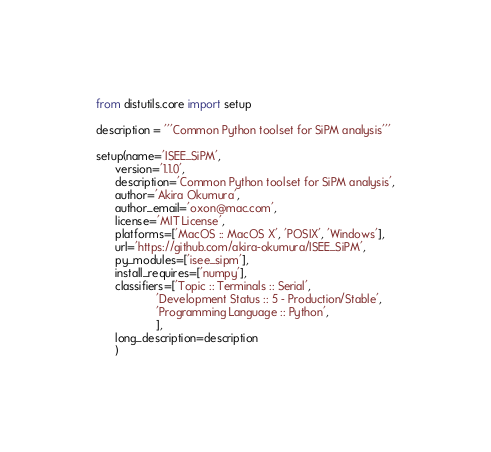<code> <loc_0><loc_0><loc_500><loc_500><_Python_>from distutils.core import setup

description = '''Common Python toolset for SiPM analysis'''

setup(name='ISEE_SiPM',
      version='1.1.0',
      description='Common Python toolset for SiPM analysis',
      author='Akira Okumura',
      author_email='oxon@mac.com',
      license='MIT License',
      platforms=['MacOS :: MacOS X', 'POSIX', 'Windows'],
      url='https://github.com/akira-okumura/ISEE_SiPM',
      py_modules=['isee_sipm'],
      install_requires=['numpy'],
      classifiers=['Topic :: Terminals :: Serial',
                   'Development Status :: 5 - Production/Stable',
                   'Programming Language :: Python',
                   ],
      long_description=description
      )
</code> 